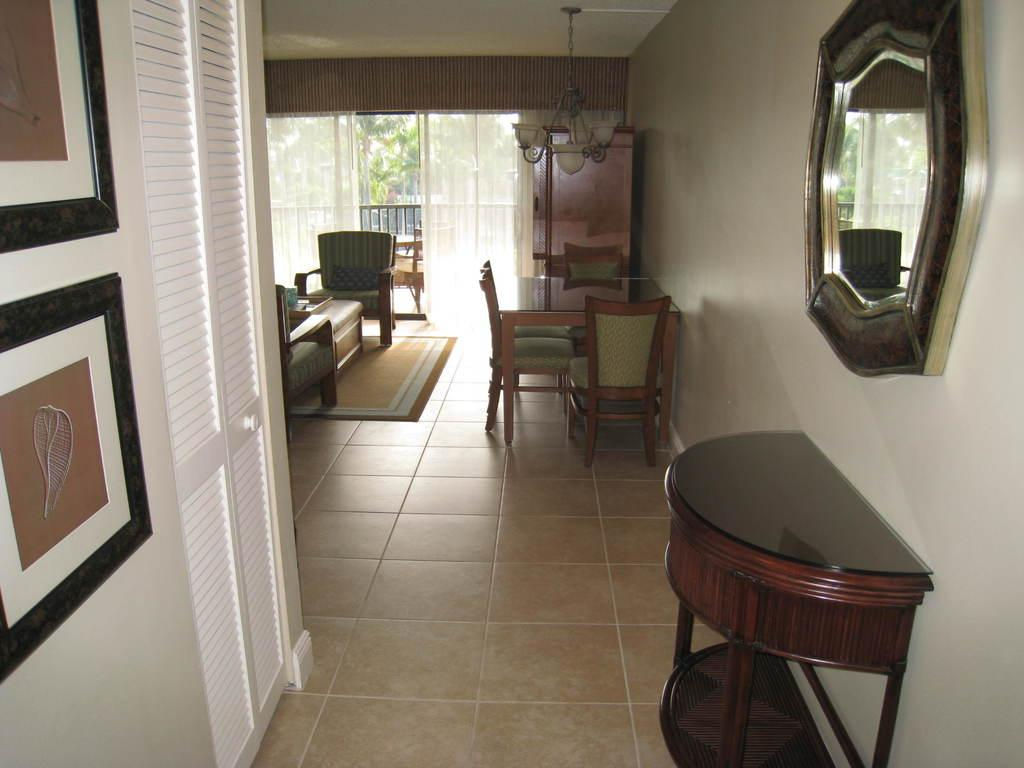What type of furniture is present in the image? There is a table and chairs in the image. What is one decorative item visible in the image? There is a mirror in the image. What type of lighting is present in the image? There are lights in the image. What is the purpose of the door in the image? The door in the image is likely used for entering or exiting the room. What type of wall decorations can be seen in the image? There are photo frames in the image. What type of window treatment is present in the image? There are curtains in the image. What type of floor covering is present in the image? There are mats in the image. What type of natural scenery is visible in the image? There are trees visible in the image. How many girls are sitting on the mats in the image? There is no mention of girls in the image; it only describes the presence of a table, chairs, a mirror, lights, a door, photo frames, curtains, mats, and trees. What type of reward is hanging from the mirror in the image? There is no mention of a reward in the image; it only describes the presence of a table, chairs, a mirror, lights, a door, photo frames, curtains, mats, and trees. 